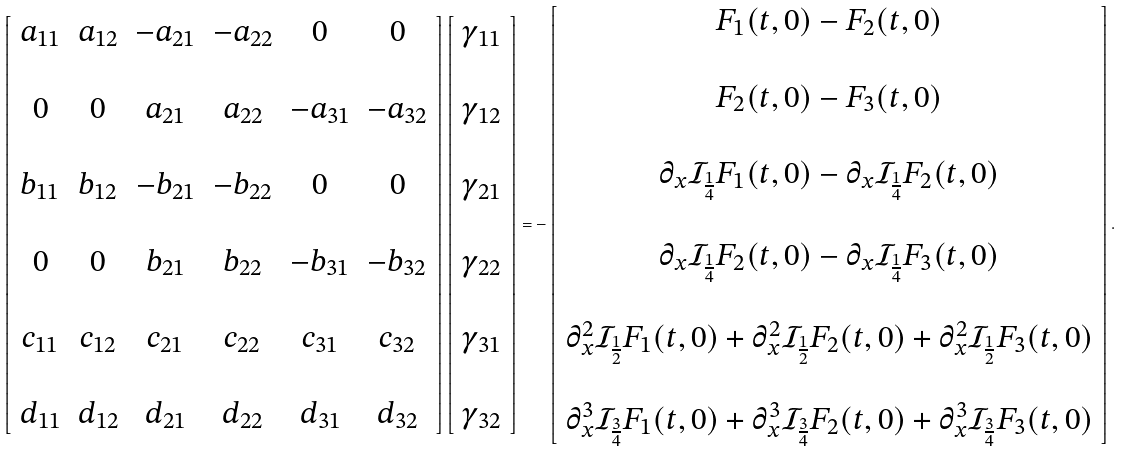<formula> <loc_0><loc_0><loc_500><loc_500>\left [ \begin{array} { c c c c c c } a _ { 1 1 } & a _ { 1 2 } & - a _ { 2 1 } & - a _ { 2 2 } & 0 & 0 \\ \\ 0 & 0 & a _ { 2 1 } & a _ { 2 2 } & - a _ { 3 1 } & - a _ { 3 2 } \\ \\ b _ { 1 1 } & b _ { 1 2 } & - b _ { 2 1 } & - b _ { 2 2 } & 0 & 0 \\ \\ 0 & 0 & b _ { 2 1 } & b _ { 2 2 } & - b _ { 3 1 } & - b _ { 3 2 } \\ \\ c _ { 1 1 } & c _ { 1 2 } & c _ { 2 1 } & c _ { 2 2 } & c _ { 3 1 } & c _ { 3 2 } \\ \\ d _ { 1 1 } & d _ { 1 2 } & d _ { 2 1 } & d _ { 2 2 } & d _ { 3 1 } & d _ { 3 2 } \\ \end{array} \right ] \left [ \begin{array} { r } \gamma _ { 1 1 } \\ \\ \gamma _ { 1 2 } \\ \\ \gamma _ { 2 1 } \\ \\ \gamma _ { 2 2 } \\ \\ \gamma _ { 3 1 } \\ \\ \gamma _ { 3 2 } \end{array} \right ] = - \left [ \begin{array} { c } F _ { 1 } ( t , 0 ) - F _ { 2 } ( t , 0 ) \\ \\ F _ { 2 } ( t , 0 ) - F _ { 3 } ( t , 0 ) \\ \\ \partial _ { x } \mathcal { I } _ { \frac { 1 } { 4 } } F _ { 1 } ( t , 0 ) - \partial _ { x } \mathcal { I } _ { \frac { 1 } { 4 } } F _ { 2 } ( t , 0 ) \\ \\ \partial _ { x } \mathcal { I } _ { \frac { 1 } { 4 } } F _ { 2 } ( t , 0 ) - \partial _ { x } \mathcal { I } _ { \frac { 1 } { 4 } } F _ { 3 } ( t , 0 ) \\ \\ \partial _ { x } ^ { 2 } \mathcal { I } _ { \frac { 1 } { 2 } } F _ { 1 } ( t , 0 ) + \partial _ { x } ^ { 2 } \mathcal { I } _ { \frac { 1 } { 2 } } F _ { 2 } ( t , 0 ) + \partial _ { x } ^ { 2 } \mathcal { I } _ { \frac { 1 } { 2 } } F _ { 3 } ( t , 0 ) \\ \\ \partial _ { x } ^ { 3 } \mathcal { I } _ { \frac { 3 } { 4 } } F _ { 1 } ( t , 0 ) + \partial _ { x } ^ { 3 } \mathcal { I } _ { \frac { 3 } { 4 } } F _ { 2 } ( t , 0 ) + \partial _ { x } ^ { 3 } \mathcal { I } _ { \frac { 3 } { 4 } } F _ { 3 } ( t , 0 ) \end{array} \right ] .</formula> 